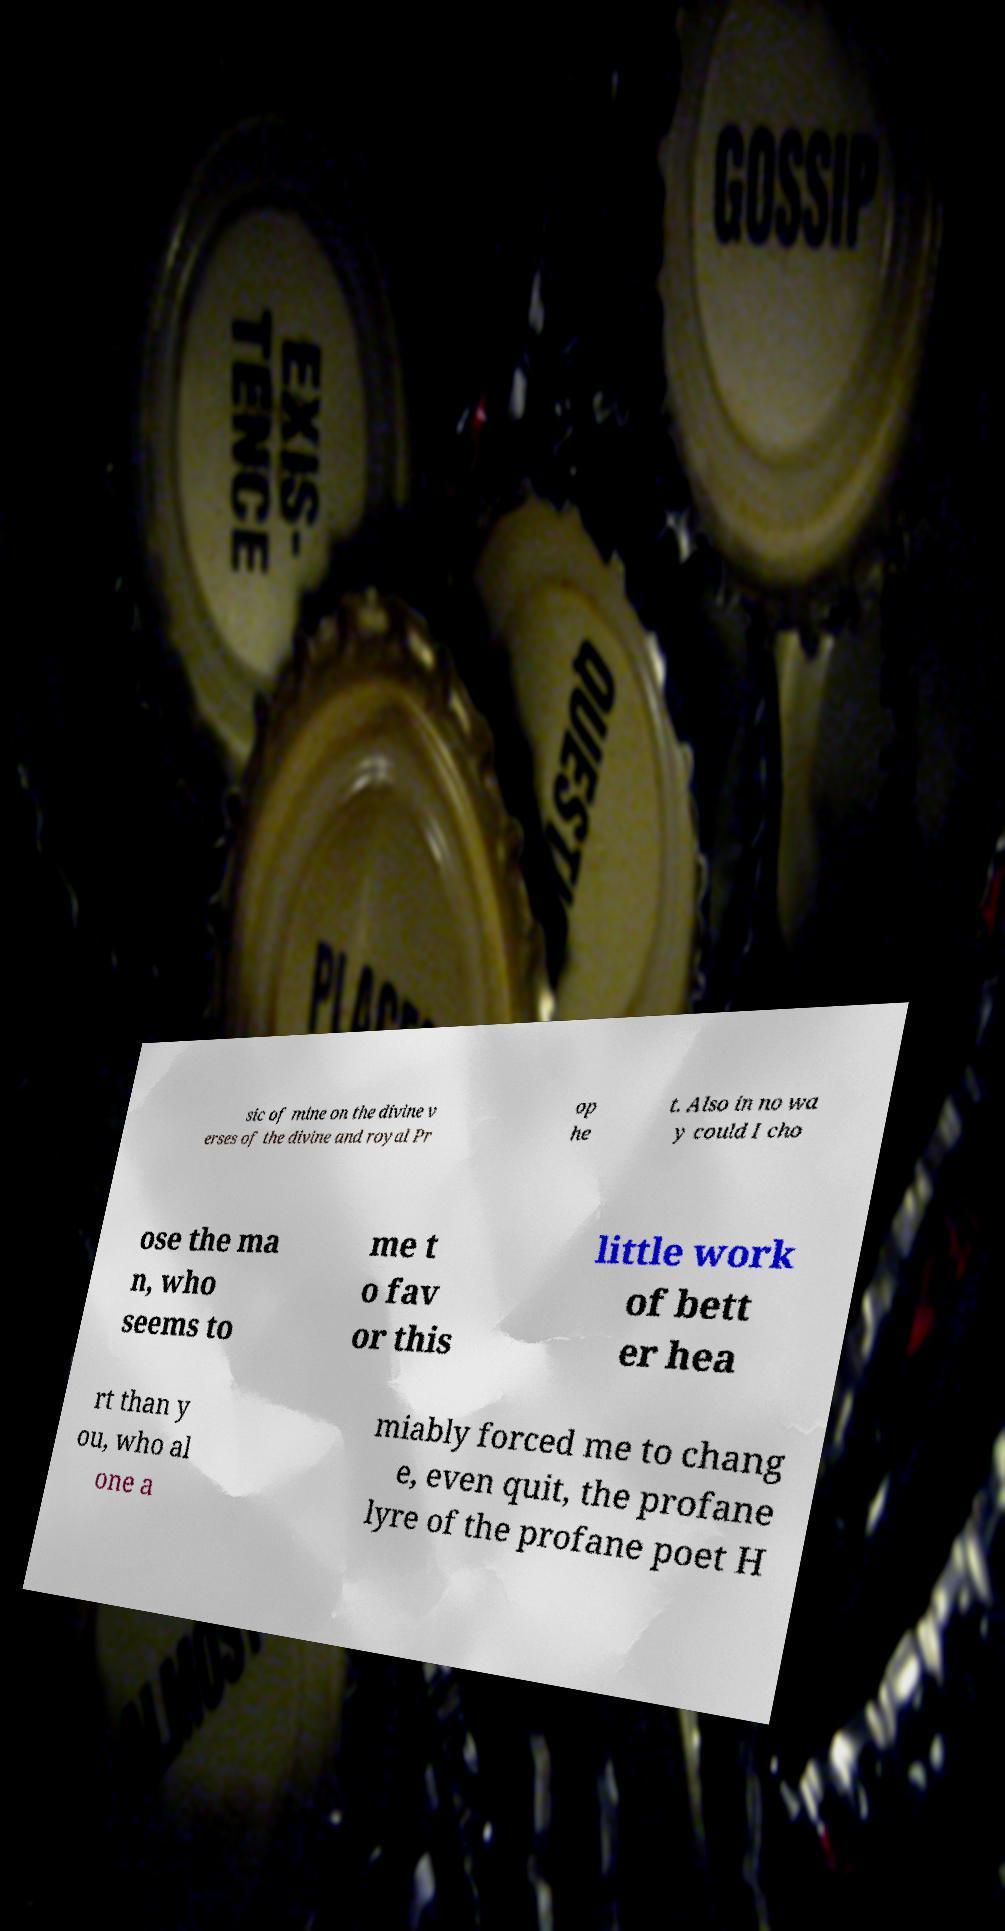Can you accurately transcribe the text from the provided image for me? sic of mine on the divine v erses of the divine and royal Pr op he t. Also in no wa y could I cho ose the ma n, who seems to me t o fav or this little work of bett er hea rt than y ou, who al one a miably forced me to chang e, even quit, the profane lyre of the profane poet H 